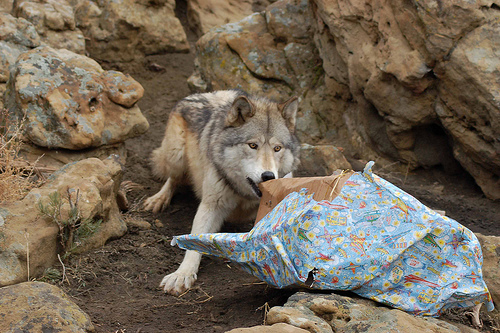<image>
Can you confirm if the dirt is under the wolf? Yes. The dirt is positioned underneath the wolf, with the wolf above it in the vertical space. Is there a wolf behind the rock? Yes. From this viewpoint, the wolf is positioned behind the rock, with the rock partially or fully occluding the wolf. Is there a wrapping paper behind the wolf? No. The wrapping paper is not behind the wolf. From this viewpoint, the wrapping paper appears to be positioned elsewhere in the scene. 